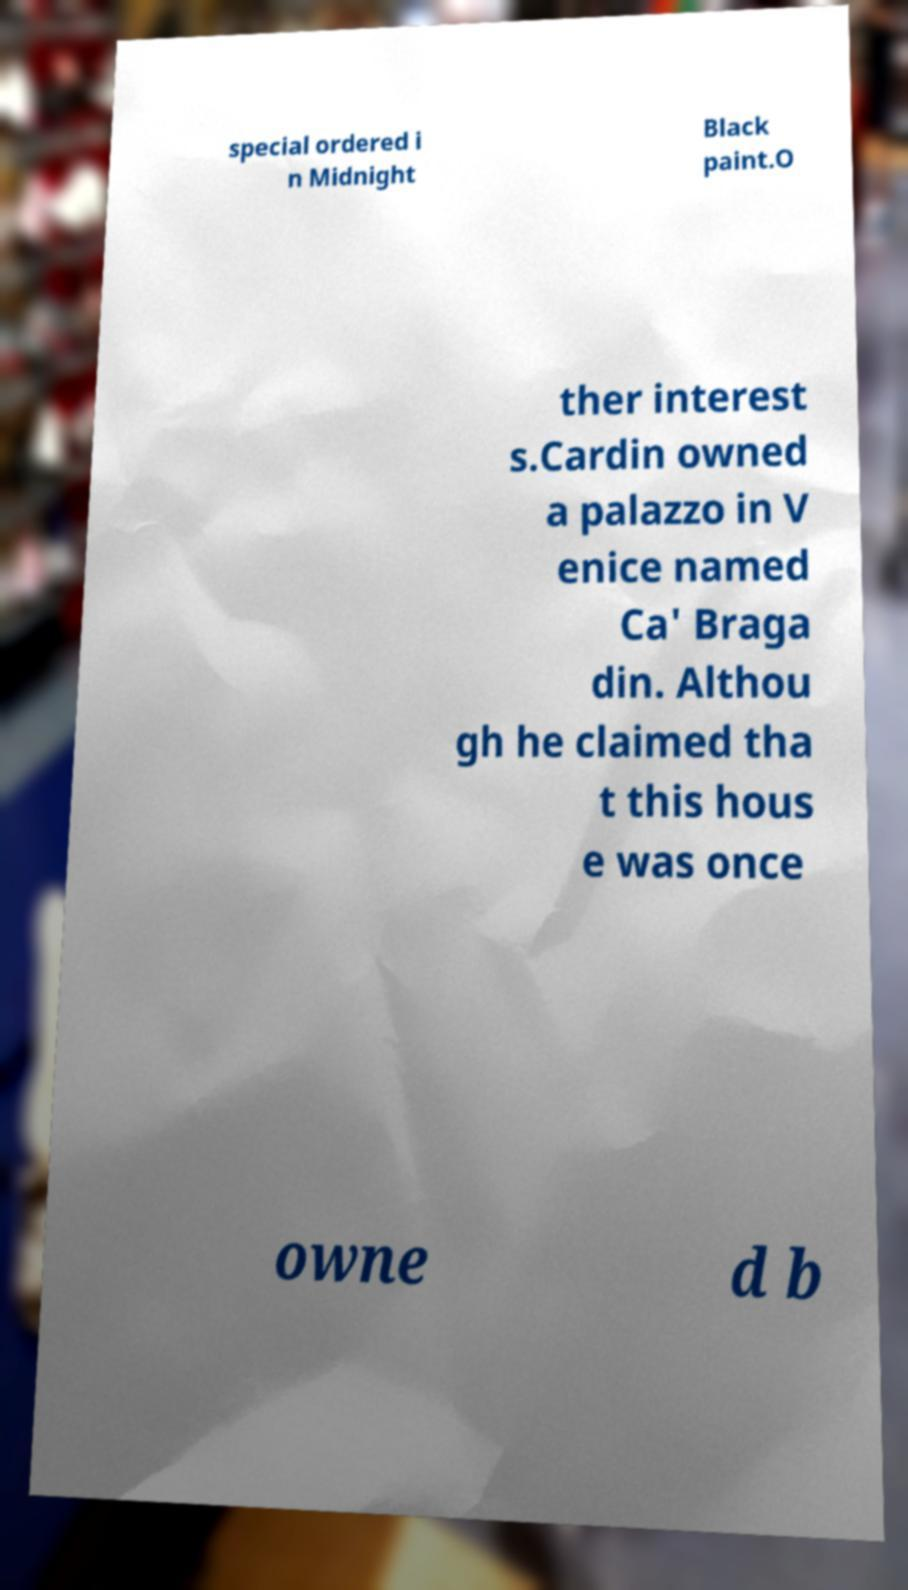Please read and relay the text visible in this image. What does it say? special ordered i n Midnight Black paint.O ther interest s.Cardin owned a palazzo in V enice named Ca' Braga din. Althou gh he claimed tha t this hous e was once owne d b 